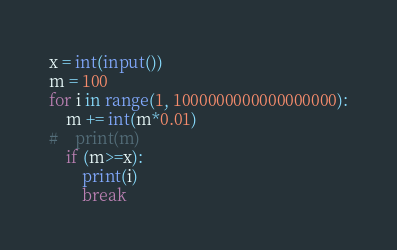Convert code to text. <code><loc_0><loc_0><loc_500><loc_500><_Python_>
x = int(input())
m = 100
for i in range(1, 1000000000000000000):
    m += int(m*0.01)
#    print(m)
    if (m>=x):
        print(i)
        break</code> 